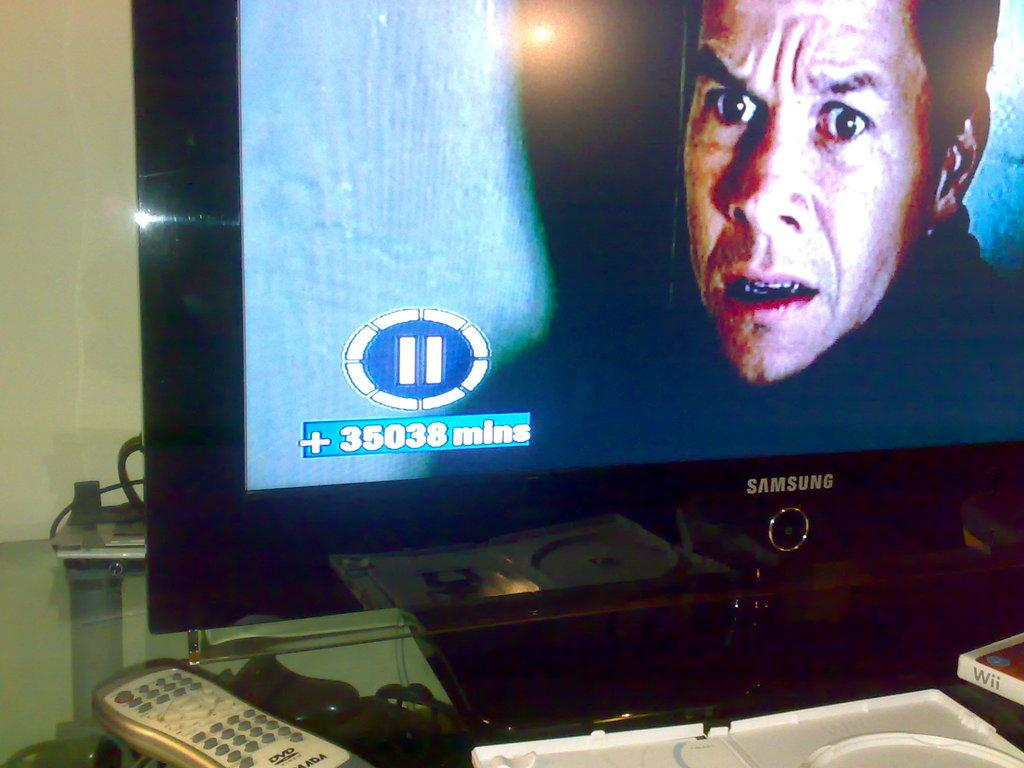What electronic device is visible in the image? There is a television in the image. What is used to control the television? There is a remote in the image. Where is the power source for the television located? There is a plug box in the image. On what surface are all three objects placed? All three objects are placed on a table. What can be seen behind the objects on the table? There is a wall in the background of the image. What type of crime is being committed in the image? There is no crime being committed in the image; it features a television, remote, and plug box on a table. How does the person in the image breathe? There is no person present in the image, so it is not possible to determine how they breathe. 